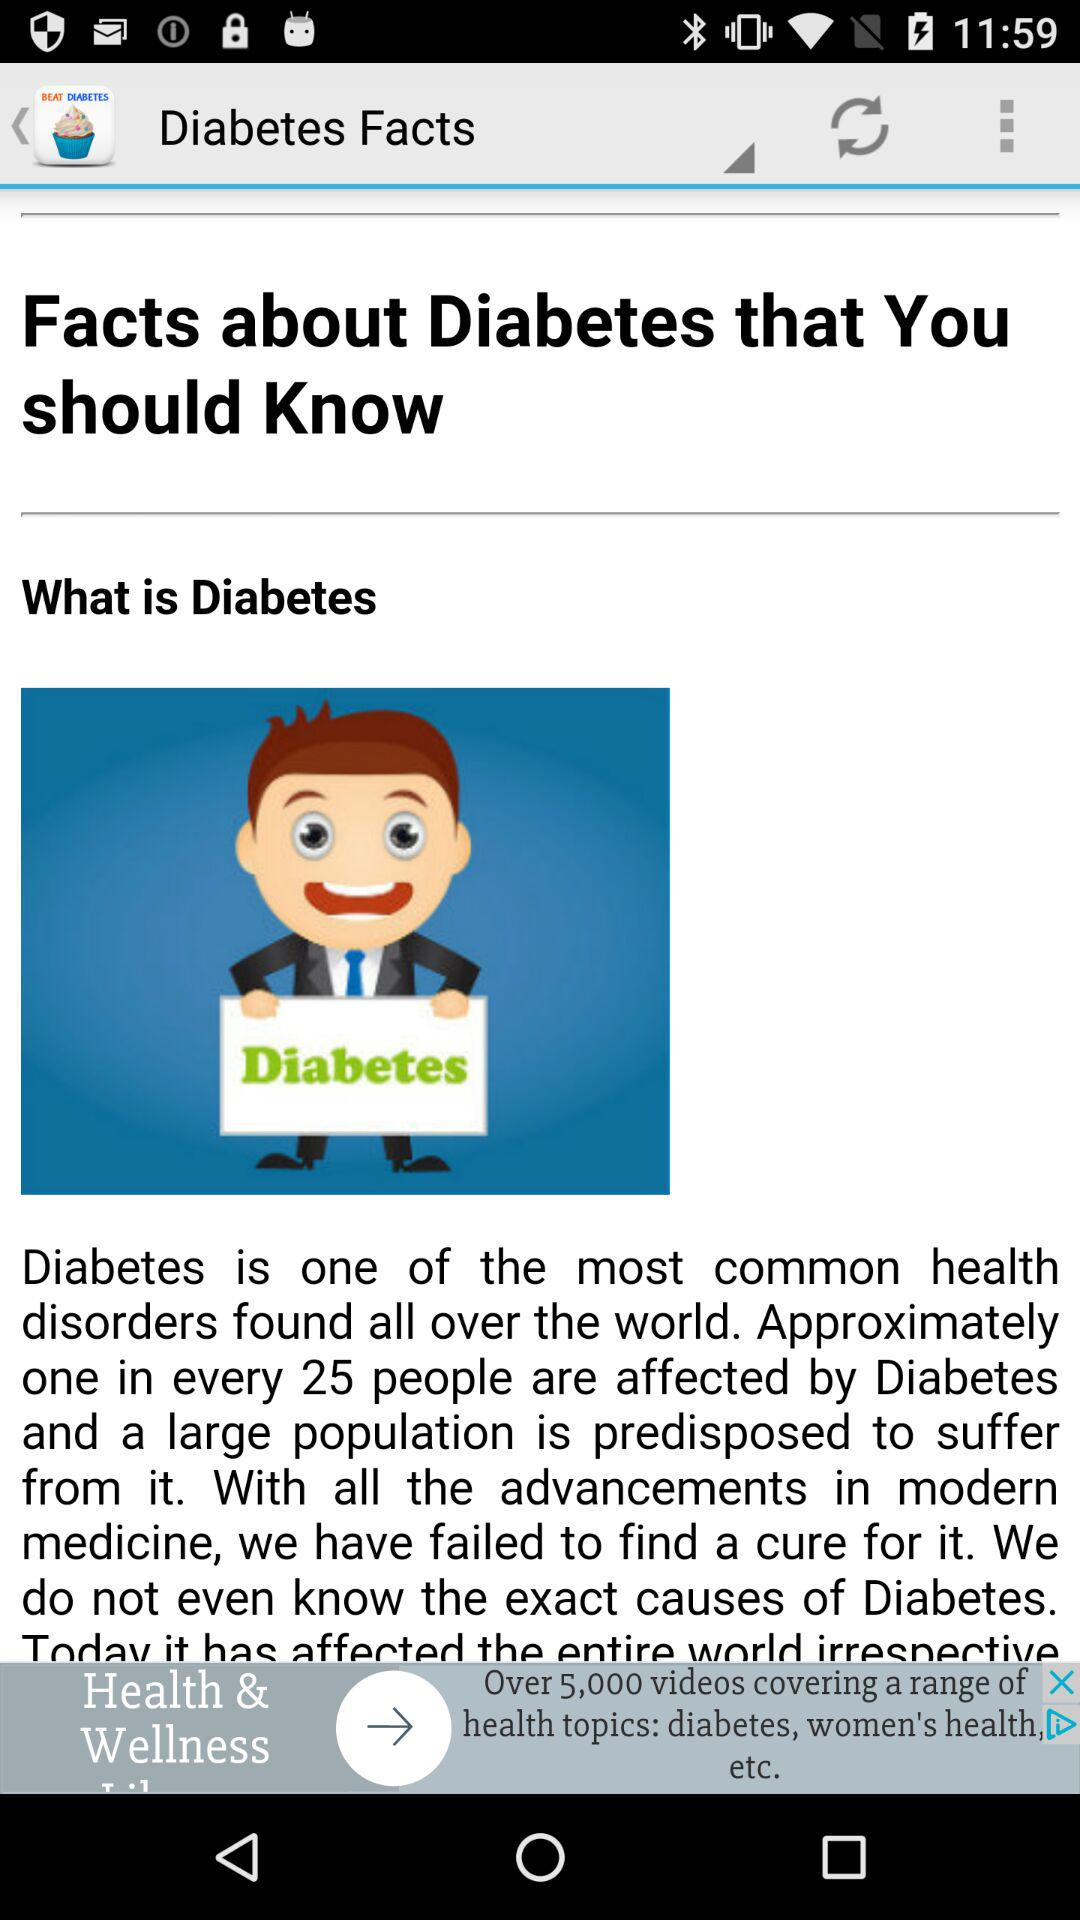How many people in every 25 are affected by diabetes? Diabetes affects one in every twenty-five people. 